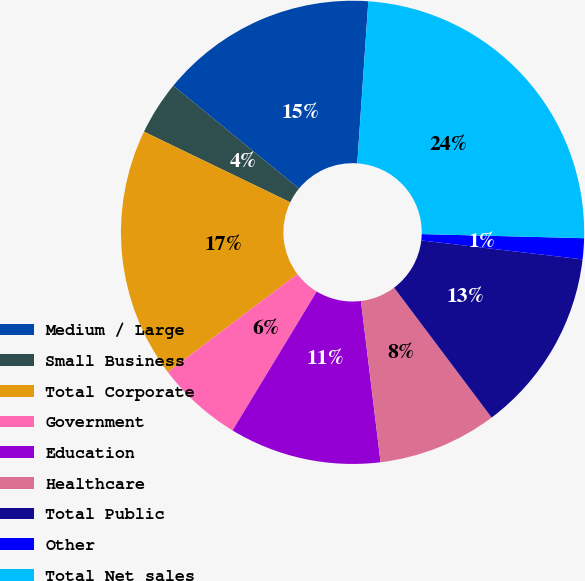Convert chart to OTSL. <chart><loc_0><loc_0><loc_500><loc_500><pie_chart><fcel>Medium / Large<fcel>Small Business<fcel>Total Corporate<fcel>Government<fcel>Education<fcel>Healthcare<fcel>Total Public<fcel>Other<fcel>Total Net sales<nl><fcel>15.18%<fcel>3.75%<fcel>17.46%<fcel>6.03%<fcel>10.6%<fcel>8.32%<fcel>12.89%<fcel>1.46%<fcel>24.32%<nl></chart> 